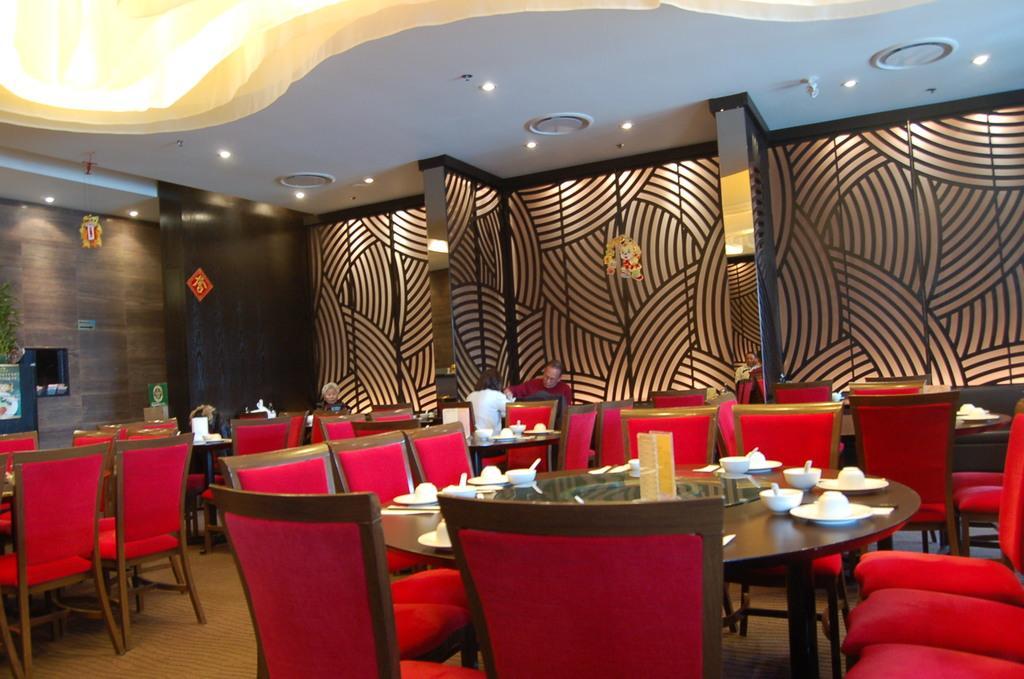Could you give a brief overview of what you see in this image? At the top we can see ceiling and lights. In the background we can see the designed wall and stickers. We can see people sitting on the chairs. On the tables we can see bowls, spoons and other objects. We can see boards. At the bottom we can see the floor. On the left side we can see a plant. 